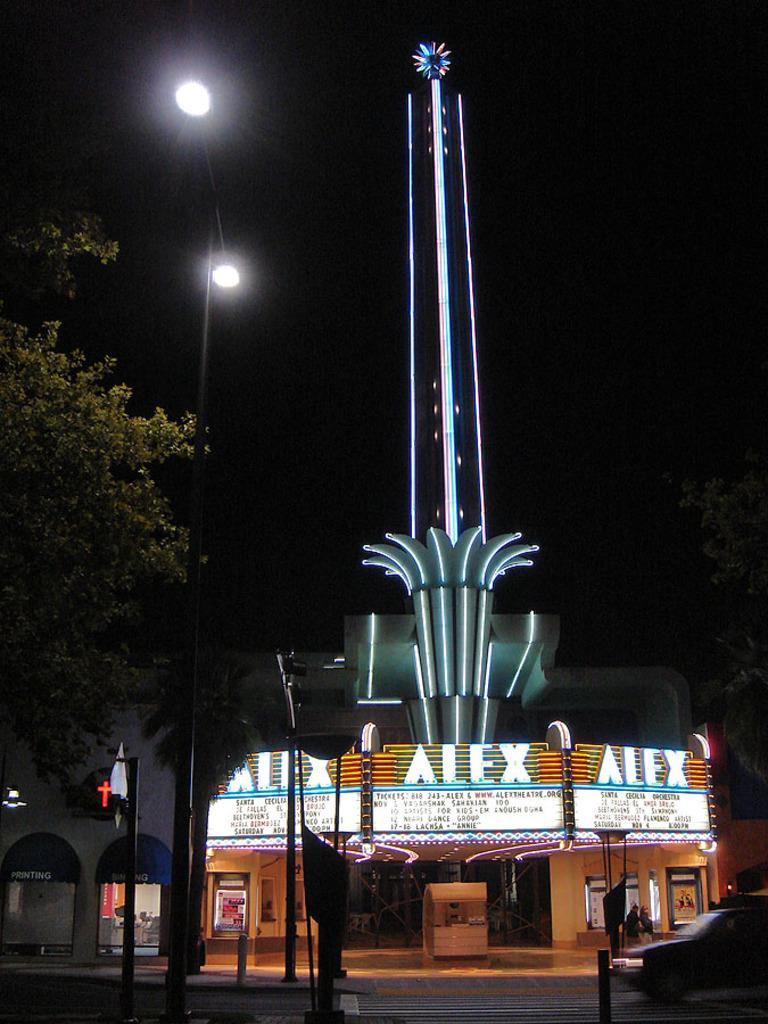What structure is the main focus of the image? There is a tower of a building in the image. What is happening in front of the building? A vehicle is moving on the road in front of the building. What type of lighting is present in the image? Street lights are present in the image. What else can be seen in the image besides the building and street lights? Poles are visible in the image. How would you describe the overall lighting in the image? The background of the image is dark. Can you see any bubbles floating around the tower in the image? There are no bubbles present in the image. Is there a sail visible on the building in the image? There is no sail present on the building in the image. 